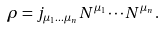Convert formula to latex. <formula><loc_0><loc_0><loc_500><loc_500>\rho = j _ { \mu _ { 1 } \dots \mu _ { n } } N ^ { \mu _ { 1 } } \cdots N ^ { \mu _ { n } } .</formula> 